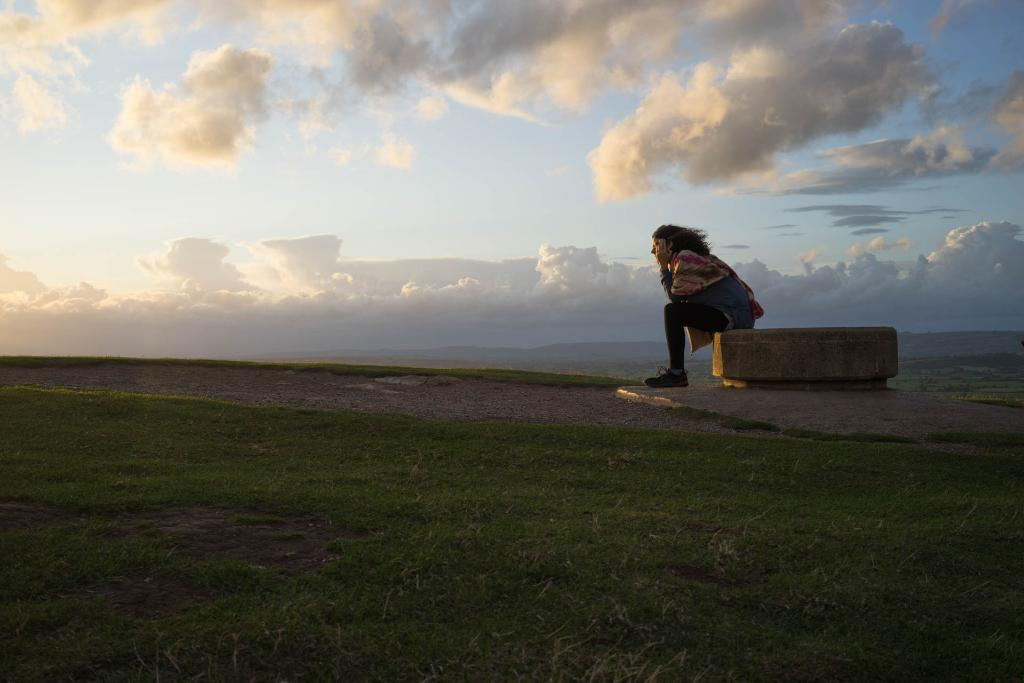What is the person in the image doing? The person is sitting on a surface in the image. What can be seen in the background of the image? There is grass and the sky visible in the image. What is the condition of the sky in the image? The sky is visible, and clouds are present in the image. How does the bulb affect the person's digestion in the image? There is no bulb present in the image, so it cannot affect the person's digestion. Is the hen laying eggs in the image? There is no hen present in the image, so it cannot be laying eggs. 